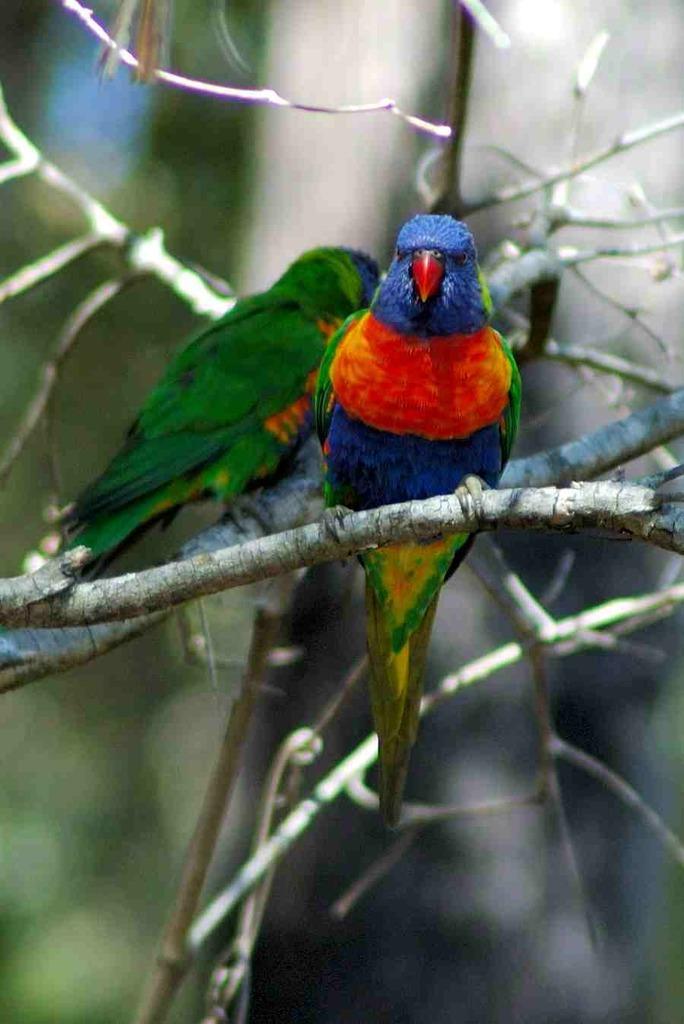In one or two sentences, can you explain what this image depicts? In this image there are two parrots visible may be on stem of tree, background is blurry. 